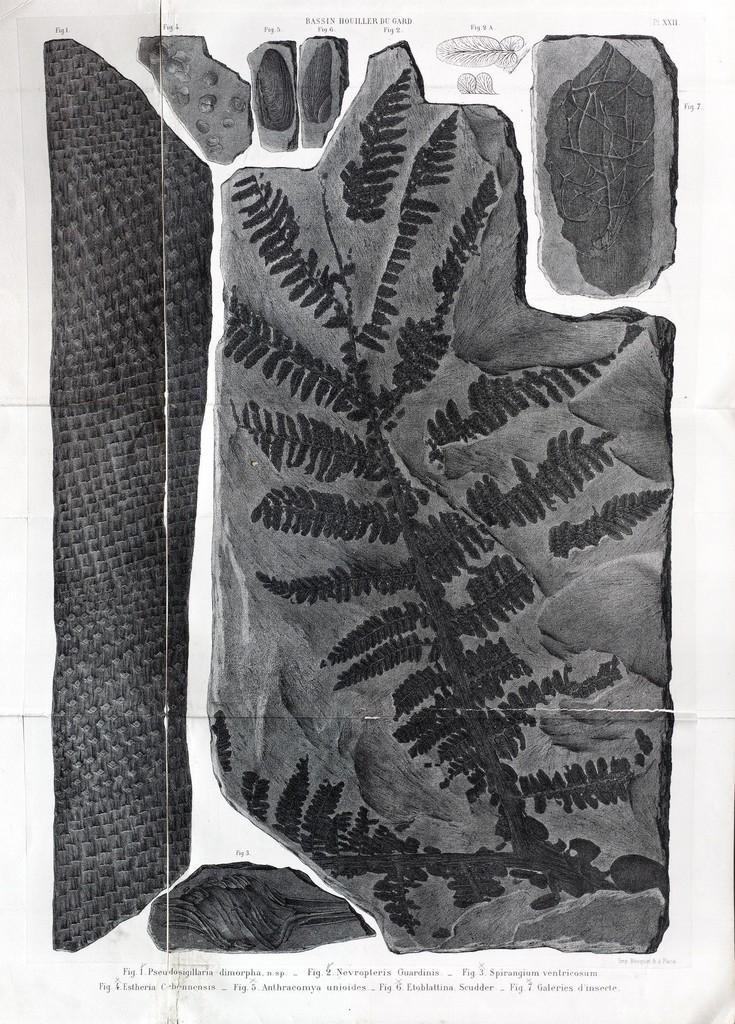Please provide a concise description of this image. This image is a black and white image. This image consists of a paper with a few images and a text on it. 